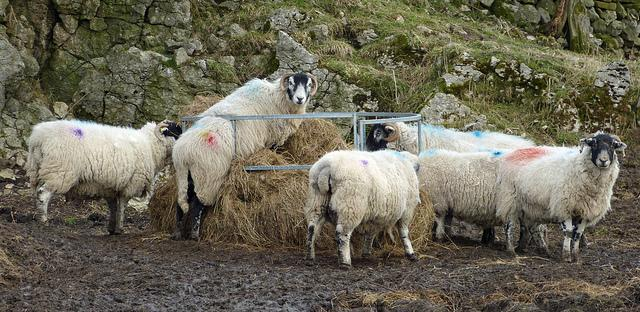What are all of the sheep gathering around in their field?

Choices:
A) dog
B) hay
C) gate
D) salt lick hay 